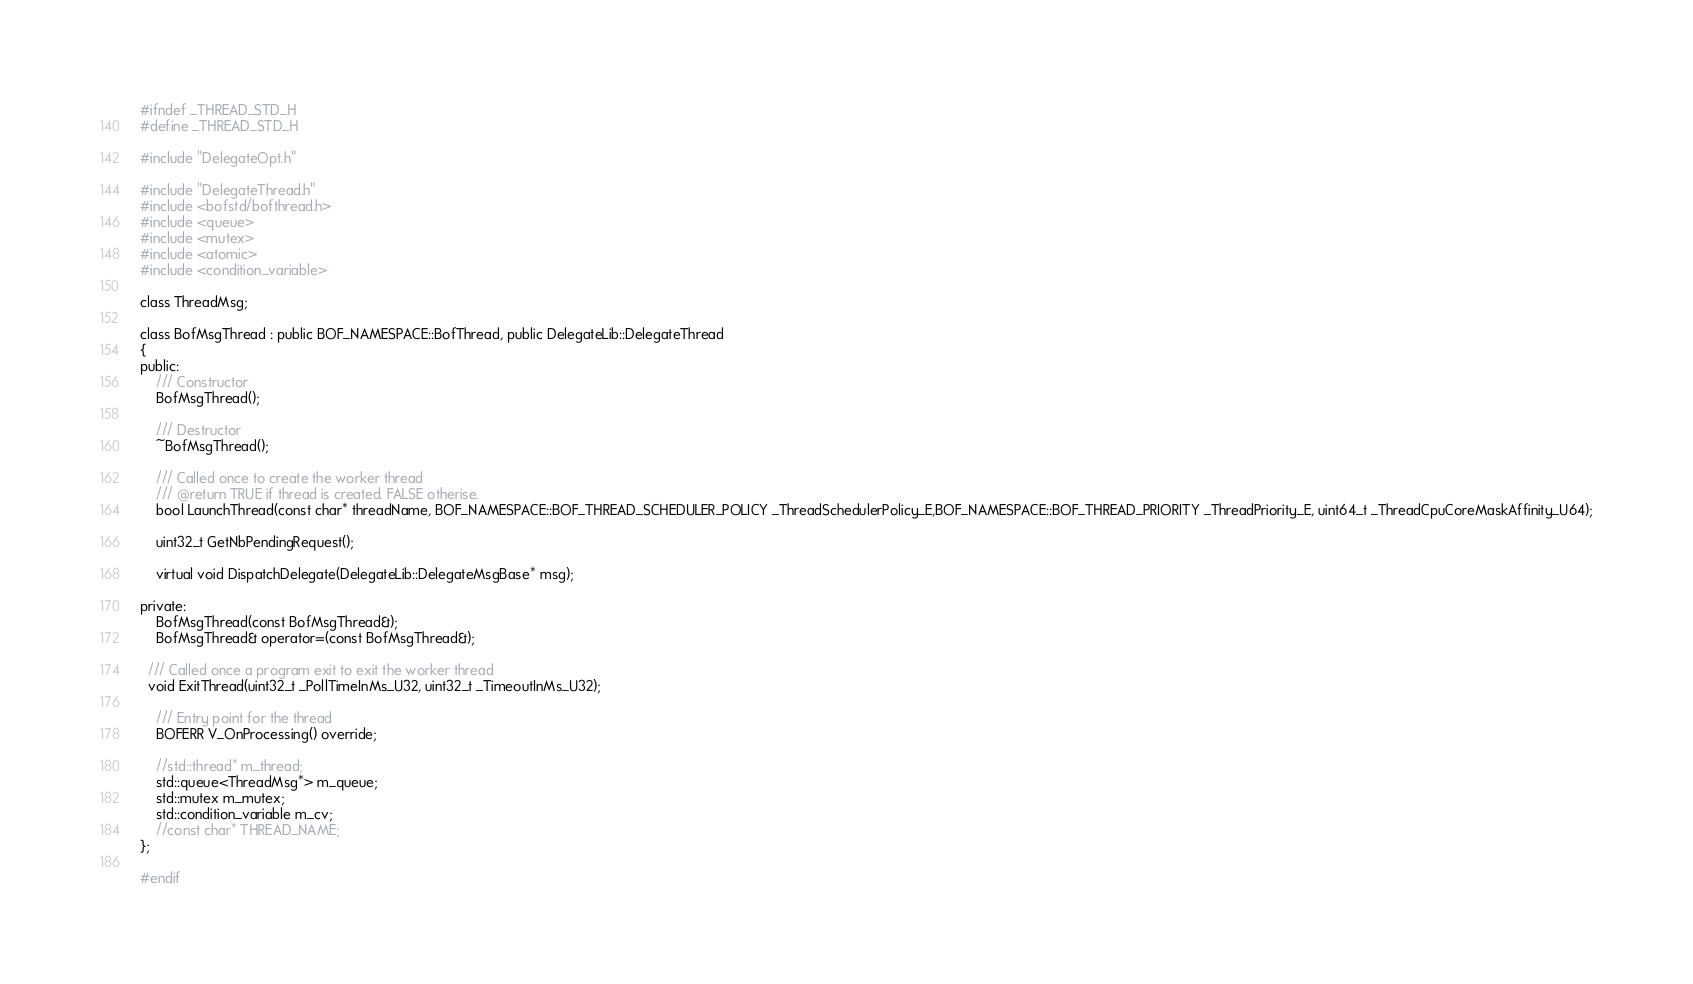<code> <loc_0><loc_0><loc_500><loc_500><_C_>#ifndef _THREAD_STD_H
#define _THREAD_STD_H

#include "DelegateOpt.h"

#include "DelegateThread.h"
#include <bofstd/bofthread.h>
#include <queue>
#include <mutex>
#include <atomic>
#include <condition_variable>

class ThreadMsg;

class BofMsgThread : public BOF_NAMESPACE::BofThread, public DelegateLib::DelegateThread
{
public:
	/// Constructor
	BofMsgThread();

	/// Destructor
	~BofMsgThread();

	/// Called once to create the worker thread
	/// @return TRUE if thread is created. FALSE otherise. 
	bool LaunchThread(const char* threadName, BOF_NAMESPACE::BOF_THREAD_SCHEDULER_POLICY _ThreadSchedulerPolicy_E,BOF_NAMESPACE::BOF_THREAD_PRIORITY _ThreadPriority_E, uint64_t _ThreadCpuCoreMaskAffinity_U64);

	uint32_t GetNbPendingRequest();

	virtual void DispatchDelegate(DelegateLib::DelegateMsgBase* msg);

private:
	BofMsgThread(const BofMsgThread&);
	BofMsgThread& operator=(const BofMsgThread&);

  /// Called once a program exit to exit the worker thread
  void ExitThread(uint32_t _PollTimeInMs_U32, uint32_t _TimeoutInMs_U32);

	/// Entry point for the thread
	BOFERR V_OnProcessing() override;

	//std::thread* m_thread;
	std::queue<ThreadMsg*> m_queue;
	std::mutex m_mutex;
	std::condition_variable m_cv;
	//const char* THREAD_NAME;
};

#endif
</code> 